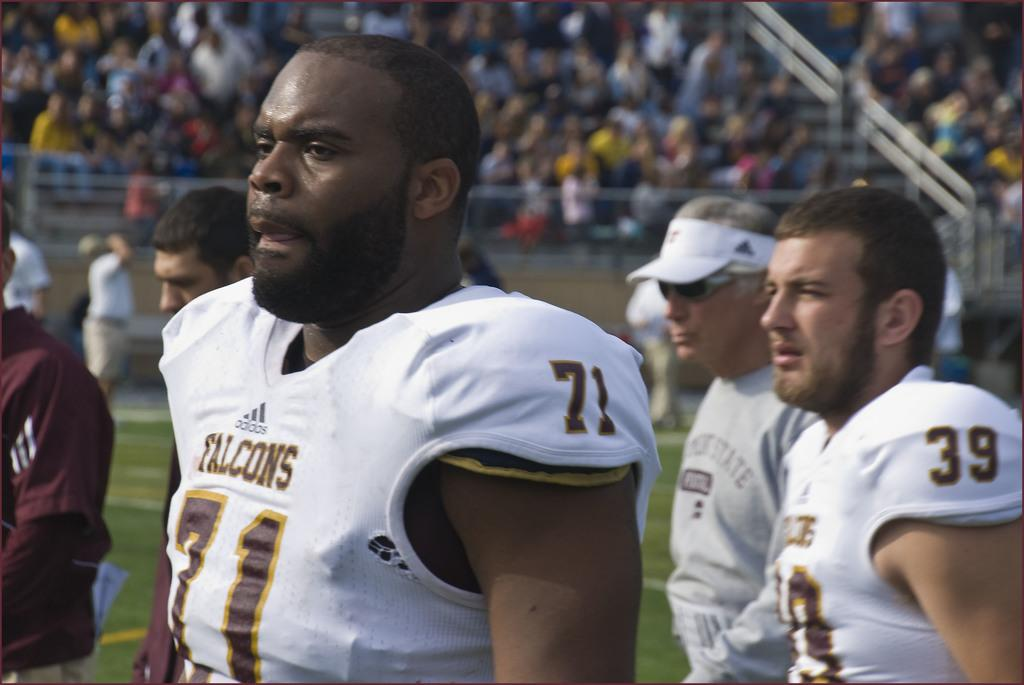What can be seen in the image? There are men standing in the image. Can you describe the attire of one of the men? One man is wearing a cap and goggles. What is visible in the background of the image? There is a crowd and a fencing visible in the background. How is the background of the image depicted? The background is blurred. What type of furniture can be seen in the image? There is no furniture present in the image. What is the weather like in the image? The provided facts do not mention the weather, so it cannot be determined from the image. 